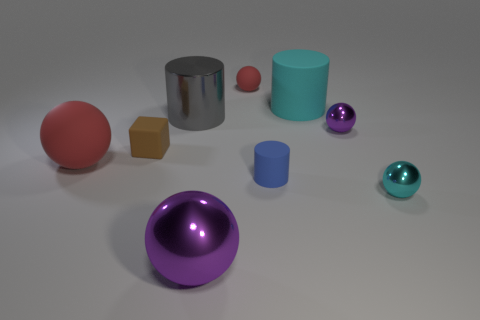Subtract 2 spheres. How many spheres are left? 3 Subtract all red cylinders. Subtract all yellow cubes. How many cylinders are left? 3 Subtract all cubes. How many objects are left? 8 Add 9 tiny cylinders. How many tiny cylinders exist? 10 Subtract 0 blue cubes. How many objects are left? 9 Subtract all big rubber spheres. Subtract all large green rubber objects. How many objects are left? 8 Add 1 small metal objects. How many small metal objects are left? 3 